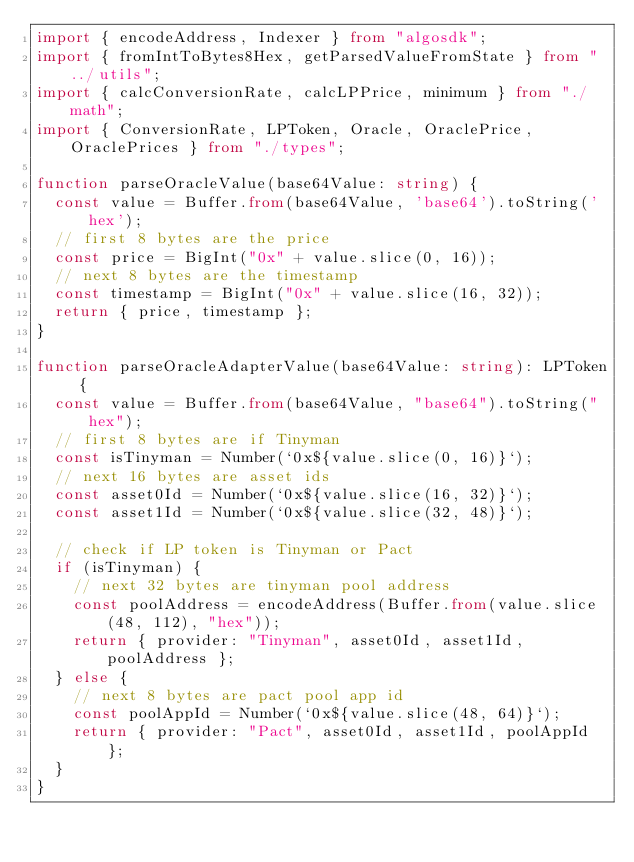<code> <loc_0><loc_0><loc_500><loc_500><_TypeScript_>import { encodeAddress, Indexer } from "algosdk";
import { fromIntToBytes8Hex, getParsedValueFromState } from "../utils";
import { calcConversionRate, calcLPPrice, minimum } from "./math";
import { ConversionRate, LPToken, Oracle, OraclePrice, OraclePrices } from "./types";

function parseOracleValue(base64Value: string) {
  const value = Buffer.from(base64Value, 'base64').toString('hex');
  // first 8 bytes are the price
  const price = BigInt("0x" + value.slice(0, 16));
  // next 8 bytes are the timestamp
  const timestamp = BigInt("0x" + value.slice(16, 32));
  return { price, timestamp };
}

function parseOracleAdapterValue(base64Value: string): LPToken {
  const value = Buffer.from(base64Value, "base64").toString("hex");
  // first 8 bytes are if Tinyman
  const isTinyman = Number(`0x${value.slice(0, 16)}`);
  // next 16 bytes are asset ids
  const asset0Id = Number(`0x${value.slice(16, 32)}`);
  const asset1Id = Number(`0x${value.slice(32, 48)}`);

  // check if LP token is Tinyman or Pact
  if (isTinyman) {
    // next 32 bytes are tinyman pool address
    const poolAddress = encodeAddress(Buffer.from(value.slice(48, 112), "hex"));
    return { provider: "Tinyman", asset0Id, asset1Id, poolAddress };
  } else {
    // next 8 bytes are pact pool app id
    const poolAppId = Number(`0x${value.slice(48, 64)}`);
    return { provider: "Pact", asset0Id, asset1Id, poolAppId };
  }
}
</code> 